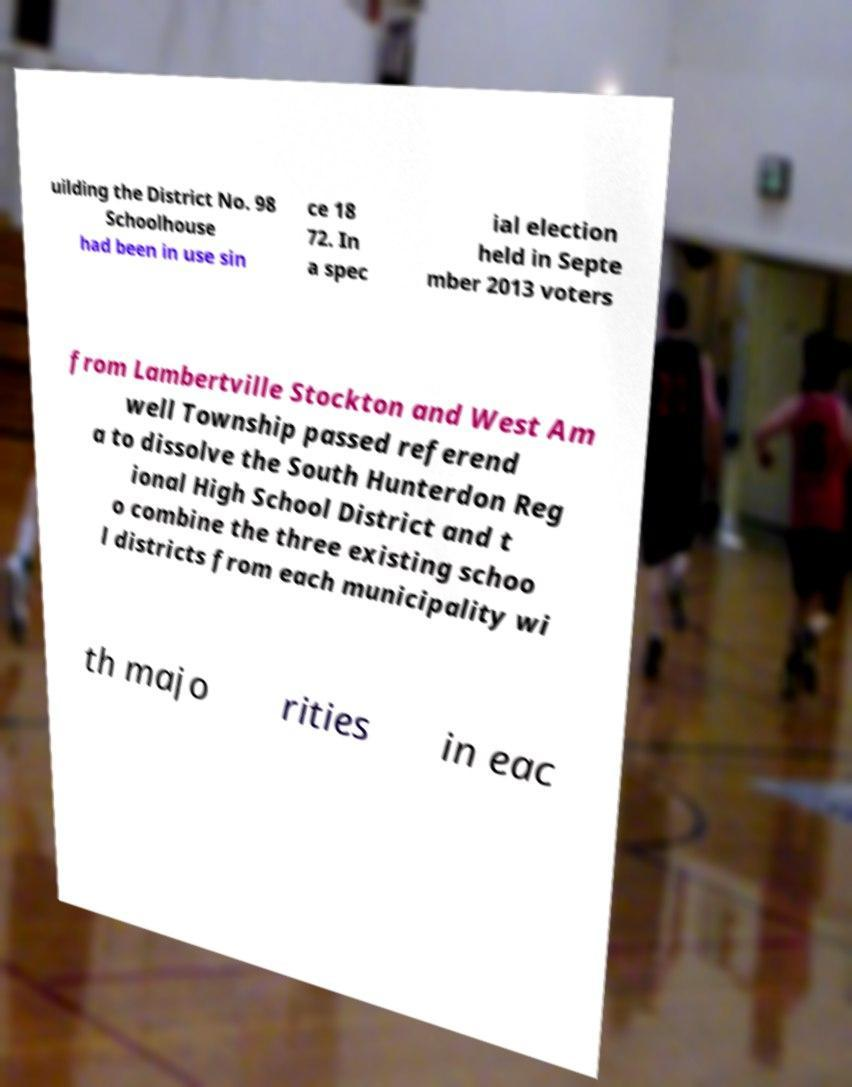There's text embedded in this image that I need extracted. Can you transcribe it verbatim? uilding the District No. 98 Schoolhouse had been in use sin ce 18 72. In a spec ial election held in Septe mber 2013 voters from Lambertville Stockton and West Am well Township passed referend a to dissolve the South Hunterdon Reg ional High School District and t o combine the three existing schoo l districts from each municipality wi th majo rities in eac 